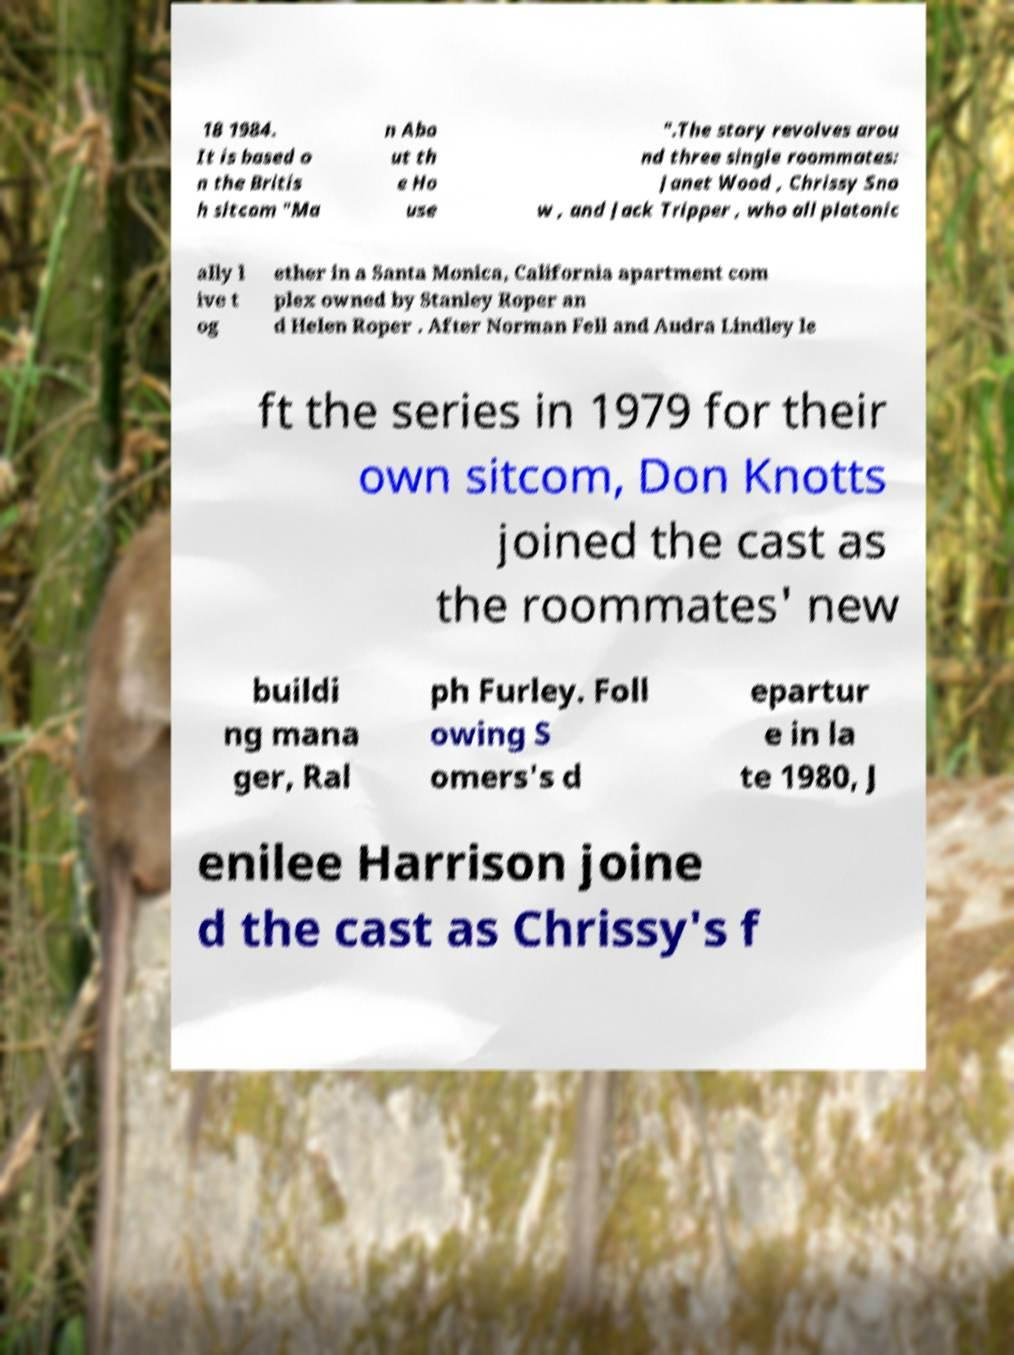For documentation purposes, I need the text within this image transcribed. Could you provide that? 18 1984. It is based o n the Britis h sitcom "Ma n Abo ut th e Ho use ".The story revolves arou nd three single roommates: Janet Wood , Chrissy Sno w , and Jack Tripper , who all platonic ally l ive t og ether in a Santa Monica, California apartment com plex owned by Stanley Roper an d Helen Roper . After Norman Fell and Audra Lindley le ft the series in 1979 for their own sitcom, Don Knotts joined the cast as the roommates' new buildi ng mana ger, Ral ph Furley. Foll owing S omers's d epartur e in la te 1980, J enilee Harrison joine d the cast as Chrissy's f 